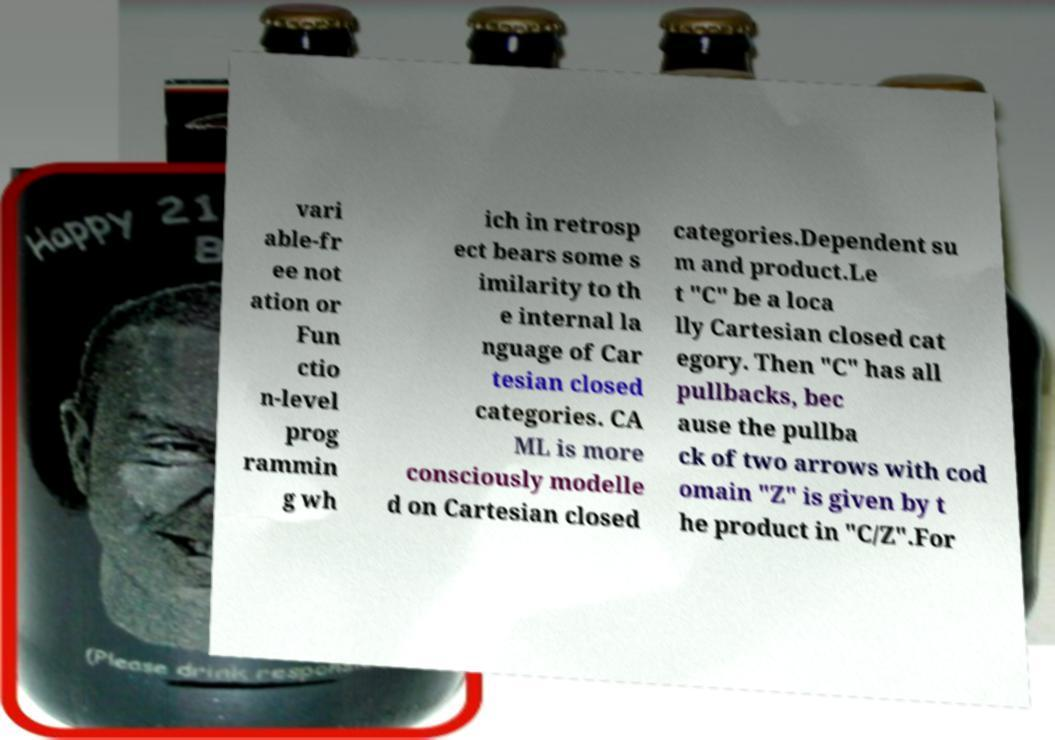What messages or text are displayed in this image? I need them in a readable, typed format. vari able-fr ee not ation or Fun ctio n-level prog rammin g wh ich in retrosp ect bears some s imilarity to th e internal la nguage of Car tesian closed categories. CA ML is more consciously modelle d on Cartesian closed categories.Dependent su m and product.Le t "C" be a loca lly Cartesian closed cat egory. Then "C" has all pullbacks, bec ause the pullba ck of two arrows with cod omain "Z" is given by t he product in "C/Z".For 